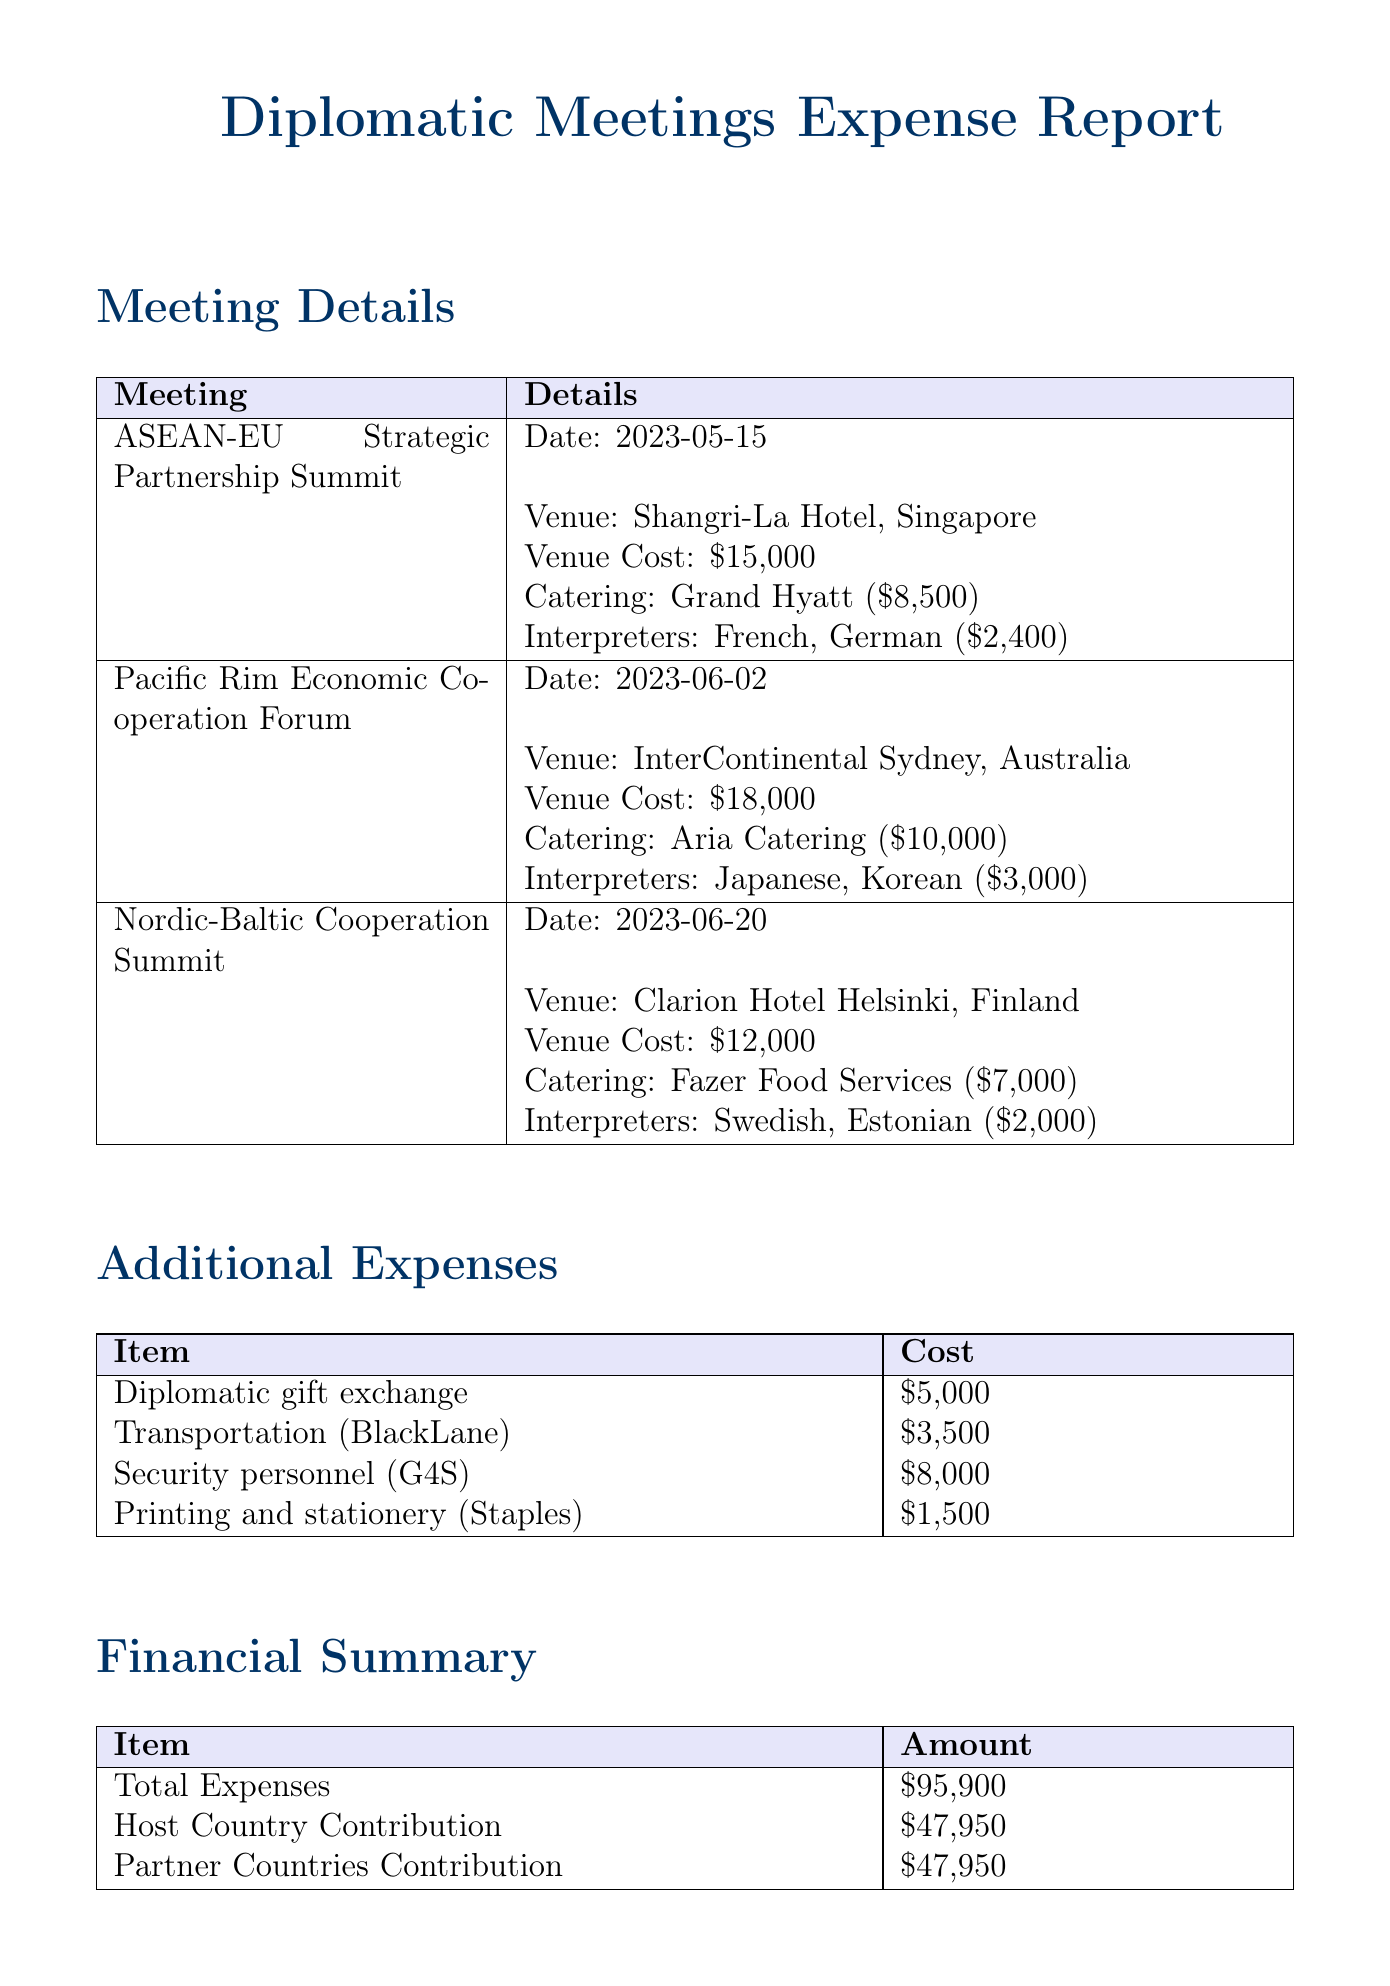What is the venue cost for the ASEAN-EU Strategic Partnership Summit? The venue cost for this meeting is specified in the document, which is $15,000.
Answer: $15,000 What date did the Nordic-Baltic Cooperation Summit take place? The date of this summit is mentioned in the document as June 20, 2023.
Answer: June 20, 2023 Who provided the catering for the Pacific Rim Economic Cooperation Forum? The document states that Aria Catering provided the catering for this forum.
Answer: Aria Catering How much was spent on interpreters for the Nordic-Baltic Cooperation Summit? The total fee for interpreters (Swedish and Estonian) in this summit amounts to $2,000, calculated from the individual fees.
Answer: $2,000 What is the total amount allocated for partner countries' contribution? The document clearly specifies that the partner countries' contribution is $47,950.
Answer: $47,950 What additional expense category has the highest cost? In the list of additional expenses, Security personnel (G4S) with a cost of $8,000 is the highest.
Answer: Security personnel (G4S) What are the two payment methods listed in the document? The payment methods described in the document are wire transfer and corporate credit card.
Answer: Wire transfer, corporate credit card Who signed the approval for this expense report? The names listed for the approval signatures in the document are Ambassador Sarah Johnson and Dr. Michael Chen.
Answer: Ambassador Sarah Johnson, Dr. Michael Chen What is the total expense amount listed in the document? The document lists the total expenses incurred, which sum up to $95,900.
Answer: $95,900 